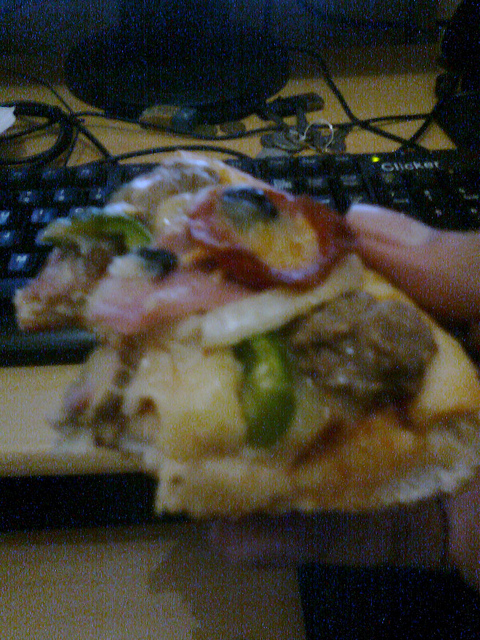What is in the foreground of the photo? The foreground prominently features a hand holding a slice of pizza with multiple toppings. 